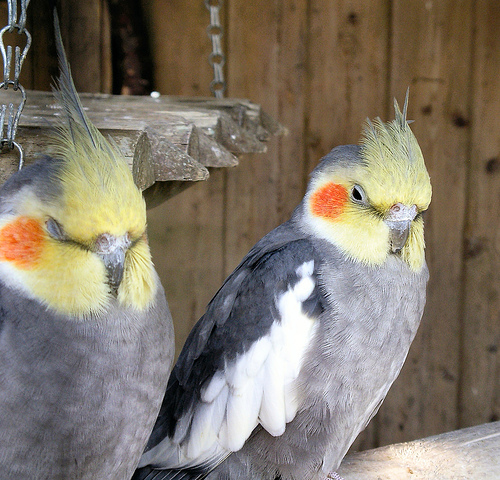<image>
Is there a beak on the bird? No. The beak is not positioned on the bird. They may be near each other, but the beak is not supported by or resting on top of the bird. 